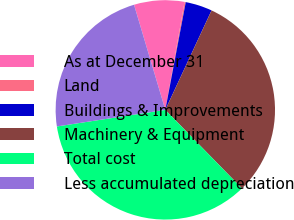<chart> <loc_0><loc_0><loc_500><loc_500><pie_chart><fcel>As at December 31<fcel>Land<fcel>Buildings & Improvements<fcel>Machinery & Equipment<fcel>Total cost<fcel>Less accumulated depreciation<nl><fcel>7.41%<fcel>0.18%<fcel>3.94%<fcel>30.77%<fcel>34.89%<fcel>22.81%<nl></chart> 